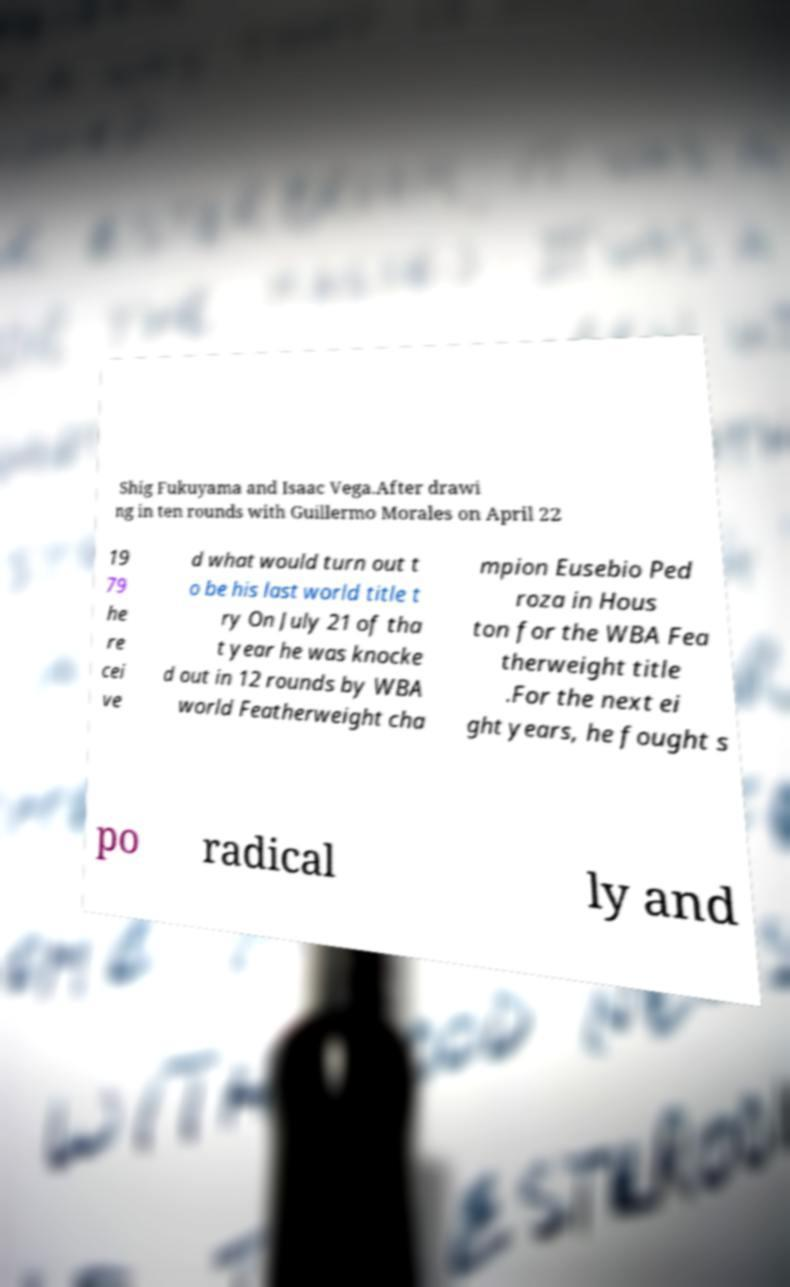Please identify and transcribe the text found in this image. Shig Fukuyama and Isaac Vega.After drawi ng in ten rounds with Guillermo Morales on April 22 19 79 he re cei ve d what would turn out t o be his last world title t ry On July 21 of tha t year he was knocke d out in 12 rounds by WBA world Featherweight cha mpion Eusebio Ped roza in Hous ton for the WBA Fea therweight title .For the next ei ght years, he fought s po radical ly and 